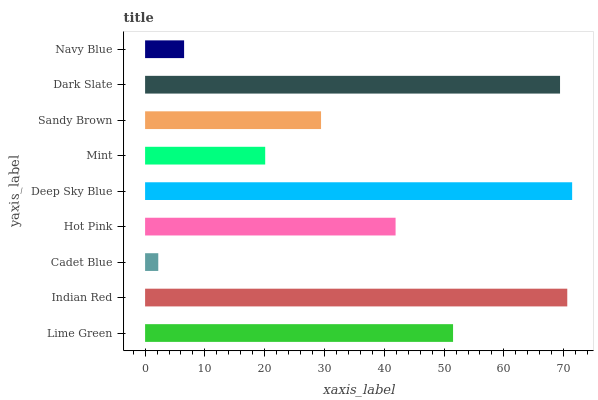Is Cadet Blue the minimum?
Answer yes or no. Yes. Is Deep Sky Blue the maximum?
Answer yes or no. Yes. Is Indian Red the minimum?
Answer yes or no. No. Is Indian Red the maximum?
Answer yes or no. No. Is Indian Red greater than Lime Green?
Answer yes or no. Yes. Is Lime Green less than Indian Red?
Answer yes or no. Yes. Is Lime Green greater than Indian Red?
Answer yes or no. No. Is Indian Red less than Lime Green?
Answer yes or no. No. Is Hot Pink the high median?
Answer yes or no. Yes. Is Hot Pink the low median?
Answer yes or no. Yes. Is Dark Slate the high median?
Answer yes or no. No. Is Navy Blue the low median?
Answer yes or no. No. 